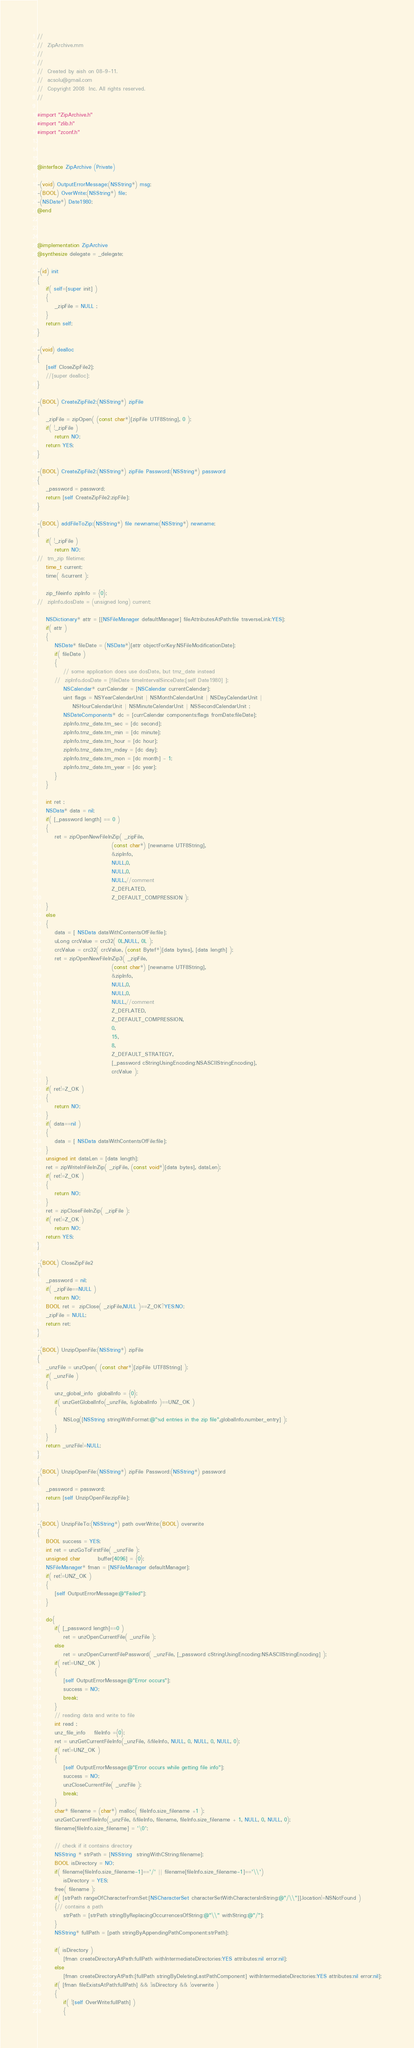Convert code to text. <code><loc_0><loc_0><loc_500><loc_500><_ObjectiveC_>//
//  ZipArchive.mm
//  
//
//  Created by aish on 08-9-11.
//  acsolu@gmail.com
//  Copyright 2008  Inc. All rights reserved.
//

#import "ZipArchive.h"
#import "zlib.h"
#import "zconf.h"



@interface ZipArchive (Private)

-(void) OutputErrorMessage:(NSString*) msg;
-(BOOL) OverWrite:(NSString*) file;
-(NSDate*) Date1980;
@end



@implementation ZipArchive
@synthesize delegate = _delegate;

-(id) init
{
	if( self=[super init] )
	{
		_zipFile = NULL ;
	}
	return self;
}

-(void) dealloc
{
	[self CloseZipFile2];
	//[super dealloc];
}

-(BOOL) CreateZipFile2:(NSString*) zipFile
{
	_zipFile = zipOpen( (const char*)[zipFile UTF8String], 0 );
	if( !_zipFile ) 
		return NO;
	return YES;
}

-(BOOL) CreateZipFile2:(NSString*) zipFile Password:(NSString*) password
{
	_password = password;
	return [self CreateZipFile2:zipFile];
}

-(BOOL) addFileToZip:(NSString*) file newname:(NSString*) newname;
{
	if( !_zipFile )
		return NO;
//	tm_zip filetime;
	time_t current;
	time( &current );
	
	zip_fileinfo zipInfo = {0};
//	zipInfo.dosDate = (unsigned long) current;
	
	NSDictionary* attr = [[NSFileManager defaultManager] fileAttributesAtPath:file traverseLink:YES];
	if( attr )
	{
		NSDate* fileDate = (NSDate*)[attr objectForKey:NSFileModificationDate];
		if( fileDate )
		{
			// some application does use dosDate, but tmz_date instead
		//	zipInfo.dosDate = [fileDate timeIntervalSinceDate:[self Date1980] ];
			NSCalendar* currCalendar = [NSCalendar currentCalendar];
			uint flags = NSYearCalendarUnit | NSMonthCalendarUnit | NSDayCalendarUnit | 
				NSHourCalendarUnit | NSMinuteCalendarUnit | NSSecondCalendarUnit ;
			NSDateComponents* dc = [currCalendar components:flags fromDate:fileDate];
			zipInfo.tmz_date.tm_sec = [dc second];
			zipInfo.tmz_date.tm_min = [dc minute];
			zipInfo.tmz_date.tm_hour = [dc hour];
			zipInfo.tmz_date.tm_mday = [dc day];
			zipInfo.tmz_date.tm_mon = [dc month] - 1;
			zipInfo.tmz_date.tm_year = [dc year];
		}
	}
	
	int ret ;
	NSData* data = nil;
	if( [_password length] == 0 )
	{
		ret = zipOpenNewFileInZip( _zipFile,
								  (const char*) [newname UTF8String],
								  &zipInfo,
								  NULL,0,
								  NULL,0,
								  NULL,//comment
								  Z_DEFLATED,
								  Z_DEFAULT_COMPRESSION );
	}
	else
	{
		data = [ NSData dataWithContentsOfFile:file];
		uLong crcValue = crc32( 0L,NULL, 0L );
		crcValue = crc32( crcValue, (const Bytef*)[data bytes], [data length] );
		ret = zipOpenNewFileInZip3( _zipFile,
								  (const char*) [newname UTF8String],
								  &zipInfo,
								  NULL,0,
								  NULL,0,
								  NULL,//comment
								  Z_DEFLATED,
								  Z_DEFAULT_COMPRESSION,
								  0,
								  15,
								  8,
								  Z_DEFAULT_STRATEGY,
								  [_password cStringUsingEncoding:NSASCIIStringEncoding],
								  crcValue );
	}
	if( ret!=Z_OK )
	{
		return NO;
	}
	if( data==nil )
	{
		data = [ NSData dataWithContentsOfFile:file];
	}
	unsigned int dataLen = [data length];
	ret = zipWriteInFileInZip( _zipFile, (const void*)[data bytes], dataLen);
	if( ret!=Z_OK )
	{
		return NO;
	}
	ret = zipCloseFileInZip( _zipFile );
	if( ret!=Z_OK )
		return NO;
	return YES;
}

-(BOOL) CloseZipFile2
{
	_password = nil;
	if( _zipFile==NULL )
		return NO;
	BOOL ret =  zipClose( _zipFile,NULL )==Z_OK?YES:NO;
	_zipFile = NULL;
	return ret;
}

-(BOOL) UnzipOpenFile:(NSString*) zipFile
{
	_unzFile = unzOpen( (const char*)[zipFile UTF8String] );
	if( _unzFile )
	{
		unz_global_info  globalInfo = {0};
		if( unzGetGlobalInfo(_unzFile, &globalInfo )==UNZ_OK )
		{
			NSLog([NSString stringWithFormat:@"%d entries in the zip file",globalInfo.number_entry] );
		}
	}
	return _unzFile!=NULL;
}

-(BOOL) UnzipOpenFile:(NSString*) zipFile Password:(NSString*) password
{
	_password = password;
	return [self UnzipOpenFile:zipFile];
}

-(BOOL) UnzipFileTo:(NSString*) path overWrite:(BOOL) overwrite
{
	BOOL success = YES;
	int ret = unzGoToFirstFile( _unzFile );
	unsigned char		buffer[4096] = {0};
	NSFileManager* fman = [NSFileManager defaultManager];
	if( ret!=UNZ_OK )
	{
		[self OutputErrorMessage:@"Failed"];
	}
	
	do{
		if( [_password length]==0 )
			ret = unzOpenCurrentFile( _unzFile );
		else
			ret = unzOpenCurrentFilePassword( _unzFile, [_password cStringUsingEncoding:NSASCIIStringEncoding] );
		if( ret!=UNZ_OK )
		{
			[self OutputErrorMessage:@"Error occurs"];
			success = NO;
			break;
		}
		// reading data and write to file
		int read ;
		unz_file_info	fileInfo ={0};
		ret = unzGetCurrentFileInfo(_unzFile, &fileInfo, NULL, 0, NULL, 0, NULL, 0);
		if( ret!=UNZ_OK )
		{
			[self OutputErrorMessage:@"Error occurs while getting file info"];
			success = NO;
			unzCloseCurrentFile( _unzFile );
			break;
		}
		char* filename = (char*) malloc( fileInfo.size_filename +1 );
		unzGetCurrentFileInfo(_unzFile, &fileInfo, filename, fileInfo.size_filename + 1, NULL, 0, NULL, 0);
		filename[fileInfo.size_filename] = '\0';
		
		// check if it contains directory
		NSString * strPath = [NSString  stringWithCString:filename];
		BOOL isDirectory = NO;
		if( filename[fileInfo.size_filename-1]=='/' || filename[fileInfo.size_filename-1]=='\\')
			isDirectory = YES;
		free( filename );
		if( [strPath rangeOfCharacterFromSet:[NSCharacterSet characterSetWithCharactersInString:@"/\\"]].location!=NSNotFound )
		{// contains a path
			strPath = [strPath stringByReplacingOccurrencesOfString:@"\\" withString:@"/"];
		}
		NSString* fullPath = [path stringByAppendingPathComponent:strPath];
		
		if( isDirectory )
			[fman createDirectoryAtPath:fullPath withIntermediateDirectories:YES attributes:nil error:nil];
		else
			[fman createDirectoryAtPath:[fullPath stringByDeletingLastPathComponent] withIntermediateDirectories:YES attributes:nil error:nil];
		if( [fman fileExistsAtPath:fullPath] && !isDirectory && !overwrite )
		{
			if( ![self OverWrite:fullPath] )
			{</code> 